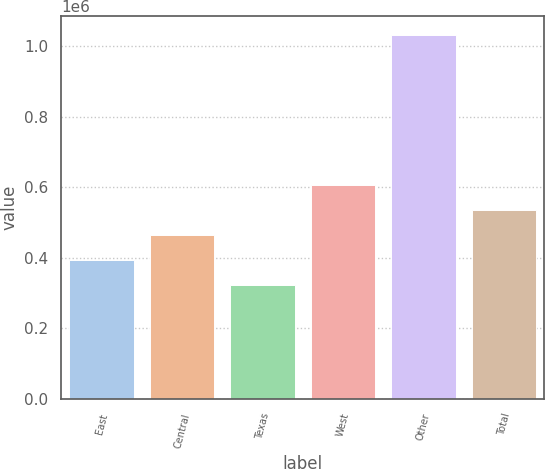Convert chart to OTSL. <chart><loc_0><loc_0><loc_500><loc_500><bar_chart><fcel>East<fcel>Central<fcel>Texas<fcel>West<fcel>Other<fcel>Total<nl><fcel>393900<fcel>464800<fcel>323000<fcel>606600<fcel>1.032e+06<fcel>535700<nl></chart> 